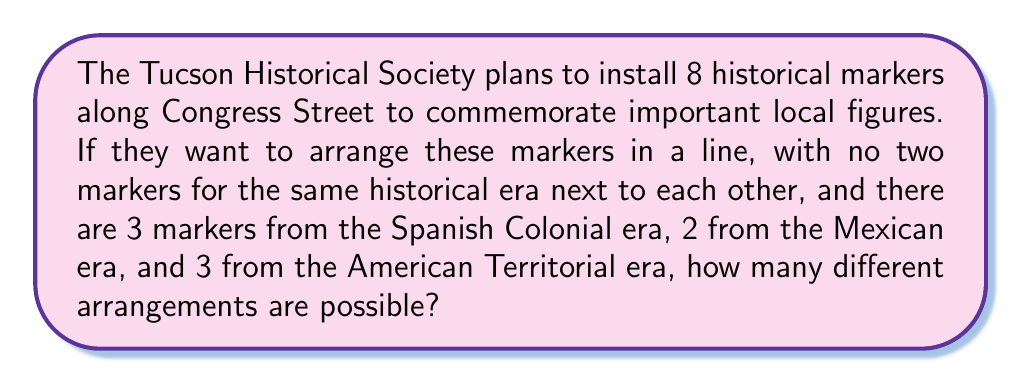Can you solve this math problem? Let's approach this step-by-step:

1) First, we need to consider the markers as distinct within their eras. This gives us:
   - 3 distinct Spanish Colonial markers (S1, S2, S3)
   - 2 distinct Mexican era markers (M1, M2)
   - 3 distinct American Territorial markers (A1, A2, A3)

2) The condition that no two markers from the same era can be adjacent means we need to arrange the eras first, and then arrange the markers within each era.

3) To arrange the eras, we have 5 positions to fill (S_M_A_), where '_' represents a position. We need to choose 3 positions for S, 2 for M, and 3 for A.

4) This is a combination problem. The number of ways to arrange the eras is:

   $$\binom{5}{3,2,3} = \frac{5!}{3!2!3!} = 10$$

5) Now, for each of these 10 arrangements of eras, we need to arrange the individual markers within their era.

6) For each arrangement:
   - The 3 Spanish Colonial markers can be arranged in 3! = 6 ways
   - The 2 Mexican era markers can be arranged in 2! = 2 ways
   - The 3 American Territorial markers can be arranged in 3! = 6 ways

7) By the multiplication principle, for each arrangement of eras, we have:

   $$6 \cdot 2 \cdot 6 = 72$$ ways to arrange the individual markers

8) Therefore, the total number of possible arrangements is:

   $$10 \cdot 72 = 720$$
Answer: 720 